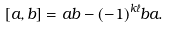<formula> <loc_0><loc_0><loc_500><loc_500>[ a , b ] = a b - ( - 1 ) ^ { k \ell } b a .</formula> 